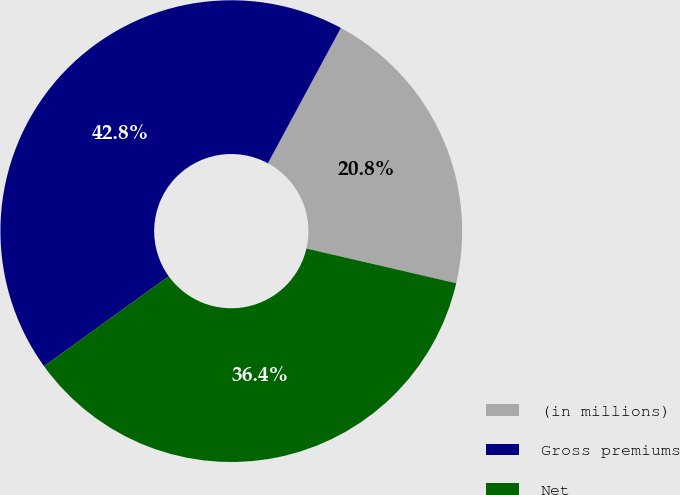Convert chart to OTSL. <chart><loc_0><loc_0><loc_500><loc_500><pie_chart><fcel>(in millions)<fcel>Gross premiums<fcel>Net<nl><fcel>20.75%<fcel>42.82%<fcel>36.43%<nl></chart> 